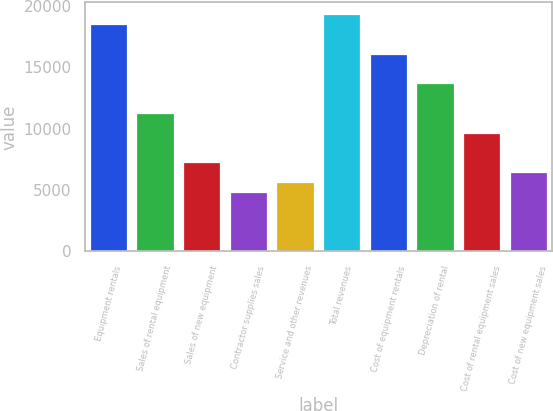<chart> <loc_0><loc_0><loc_500><loc_500><bar_chart><fcel>Equipment rentals<fcel>Sales of rental equipment<fcel>Sales of new equipment<fcel>Contractor supplies sales<fcel>Service and other revenues<fcel>Total revenues<fcel>Cost of equipment rentals<fcel>Depreciation of rental<fcel>Cost of rental equipment sales<fcel>Cost of new equipment sales<nl><fcel>18500.3<fcel>11263.4<fcel>7242.9<fcel>4830.6<fcel>5634.7<fcel>19304.4<fcel>16088<fcel>13675.7<fcel>9655.2<fcel>6438.8<nl></chart> 